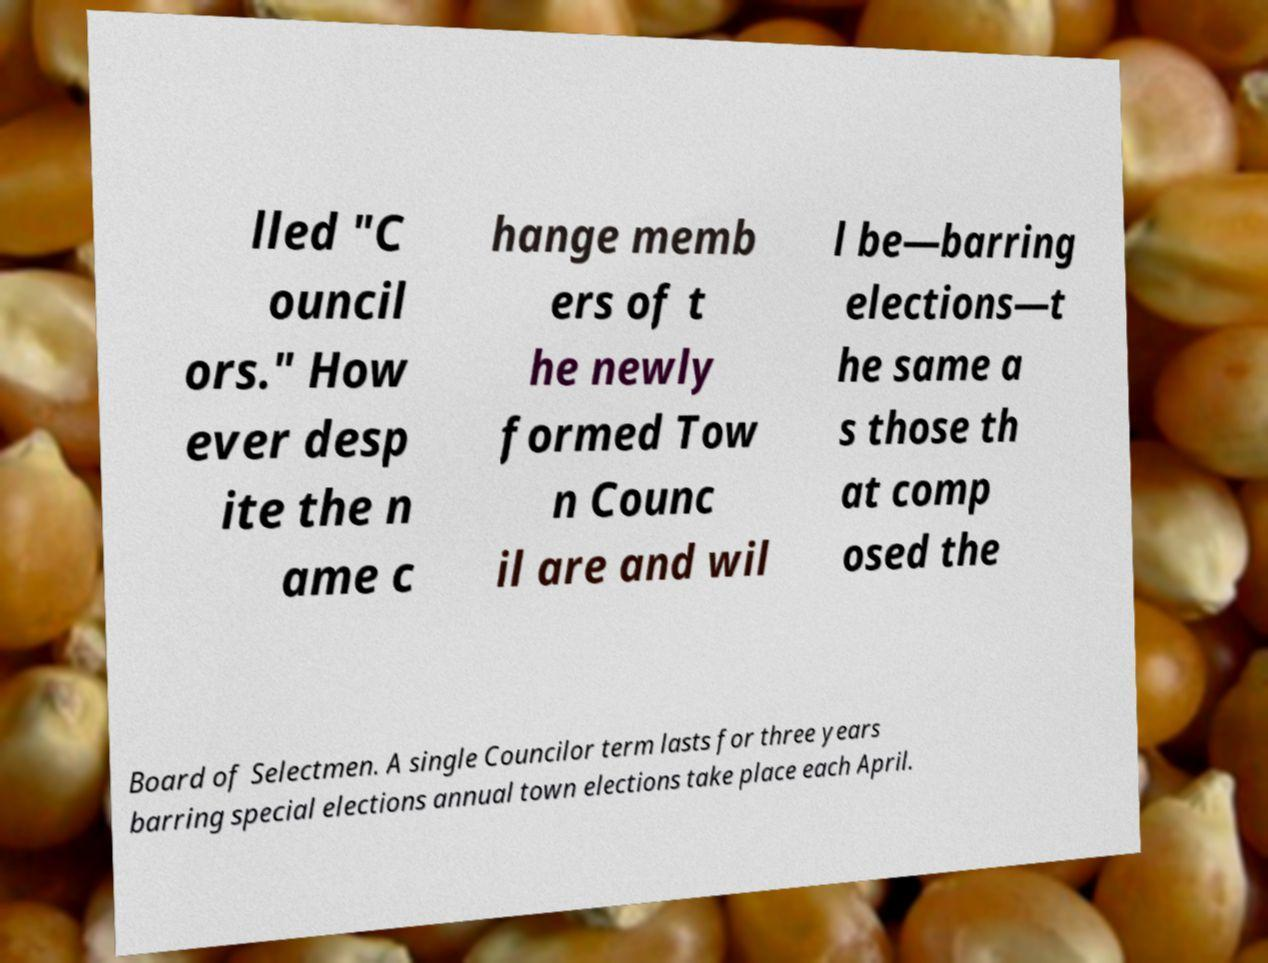Please identify and transcribe the text found in this image. lled "C ouncil ors." How ever desp ite the n ame c hange memb ers of t he newly formed Tow n Counc il are and wil l be—barring elections—t he same a s those th at comp osed the Board of Selectmen. A single Councilor term lasts for three years barring special elections annual town elections take place each April. 